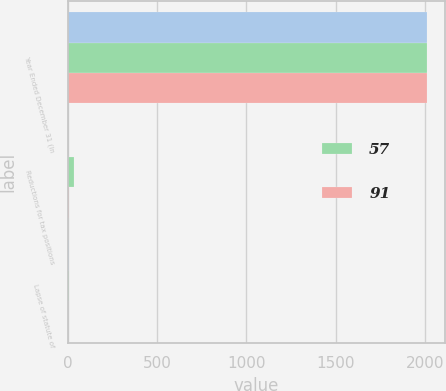<chart> <loc_0><loc_0><loc_500><loc_500><stacked_bar_chart><ecel><fcel>Year Ended December 31 (In<fcel>Reductions for tax positions<fcel>Lapse of statute of<nl><fcel>nan<fcel>2015<fcel>3<fcel>7<nl><fcel>57<fcel>2014<fcel>35<fcel>5<nl><fcel>91<fcel>2013<fcel>7<fcel>2<nl></chart> 